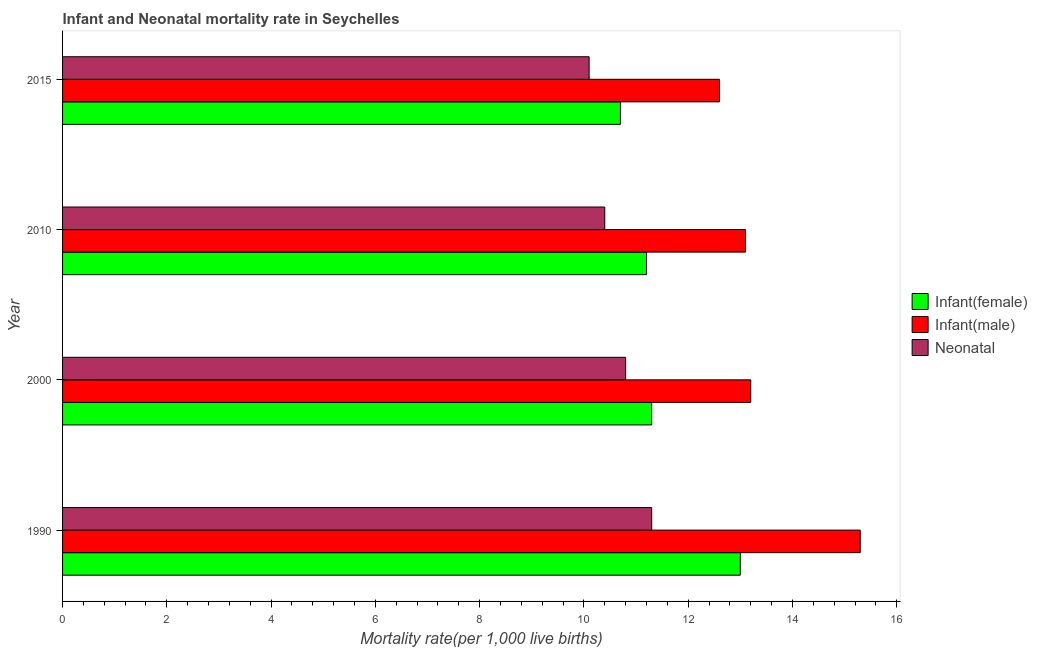How many groups of bars are there?
Provide a succinct answer. 4. How many bars are there on the 2nd tick from the top?
Your response must be concise. 3. How many bars are there on the 1st tick from the bottom?
Offer a very short reply. 3. What is the label of the 2nd group of bars from the top?
Offer a very short reply. 2010. Across all years, what is the minimum infant mortality rate(female)?
Offer a terse response. 10.7. In which year was the infant mortality rate(male) maximum?
Make the answer very short. 1990. In which year was the infant mortality rate(female) minimum?
Your answer should be very brief. 2015. What is the total infant mortality rate(male) in the graph?
Your answer should be very brief. 54.2. What is the difference between the neonatal mortality rate in 2010 and that in 2015?
Provide a short and direct response. 0.3. What is the difference between the infant mortality rate(female) in 2010 and the infant mortality rate(male) in 2015?
Provide a succinct answer. -1.4. What is the average infant mortality rate(male) per year?
Your answer should be very brief. 13.55. What is the ratio of the infant mortality rate(male) in 1990 to that in 2000?
Your answer should be very brief. 1.16. What is the difference between the highest and the lowest infant mortality rate(male)?
Provide a short and direct response. 2.7. Is the sum of the infant mortality rate(male) in 1990 and 2010 greater than the maximum neonatal mortality rate across all years?
Your response must be concise. Yes. What does the 3rd bar from the top in 2015 represents?
Give a very brief answer. Infant(female). What does the 2nd bar from the bottom in 1990 represents?
Give a very brief answer. Infant(male). Is it the case that in every year, the sum of the infant mortality rate(female) and infant mortality rate(male) is greater than the neonatal mortality rate?
Ensure brevity in your answer.  Yes. How many bars are there?
Offer a very short reply. 12. Are all the bars in the graph horizontal?
Keep it short and to the point. Yes. Are the values on the major ticks of X-axis written in scientific E-notation?
Your answer should be compact. No. Does the graph contain any zero values?
Keep it short and to the point. No. Where does the legend appear in the graph?
Keep it short and to the point. Center right. What is the title of the graph?
Your answer should be compact. Infant and Neonatal mortality rate in Seychelles. What is the label or title of the X-axis?
Keep it short and to the point. Mortality rate(per 1,0 live births). What is the Mortality rate(per 1,000 live births) of Infant(female) in 1990?
Provide a succinct answer. 13. What is the Mortality rate(per 1,000 live births) of Infant(male) in 1990?
Give a very brief answer. 15.3. What is the Mortality rate(per 1,000 live births) in Neonatal  in 2000?
Ensure brevity in your answer.  10.8. Across all years, what is the maximum Mortality rate(per 1,000 live births) in Infant(male)?
Offer a terse response. 15.3. Across all years, what is the maximum Mortality rate(per 1,000 live births) in Neonatal ?
Make the answer very short. 11.3. Across all years, what is the minimum Mortality rate(per 1,000 live births) of Infant(female)?
Your answer should be compact. 10.7. Across all years, what is the minimum Mortality rate(per 1,000 live births) of Neonatal ?
Your answer should be compact. 10.1. What is the total Mortality rate(per 1,000 live births) of Infant(female) in the graph?
Offer a terse response. 46.2. What is the total Mortality rate(per 1,000 live births) of Infant(male) in the graph?
Offer a terse response. 54.2. What is the total Mortality rate(per 1,000 live births) in Neonatal  in the graph?
Keep it short and to the point. 42.6. What is the difference between the Mortality rate(per 1,000 live births) in Infant(male) in 1990 and that in 2000?
Your answer should be compact. 2.1. What is the difference between the Mortality rate(per 1,000 live births) of Infant(male) in 1990 and that in 2010?
Provide a short and direct response. 2.2. What is the difference between the Mortality rate(per 1,000 live births) of Infant(female) in 2000 and that in 2010?
Provide a succinct answer. 0.1. What is the difference between the Mortality rate(per 1,000 live births) of Infant(male) in 2000 and that in 2010?
Your answer should be compact. 0.1. What is the difference between the Mortality rate(per 1,000 live births) of Infant(female) in 2000 and that in 2015?
Your answer should be compact. 0.6. What is the difference between the Mortality rate(per 1,000 live births) in Infant(male) in 2000 and that in 2015?
Offer a terse response. 0.6. What is the difference between the Mortality rate(per 1,000 live births) of Infant(male) in 2010 and that in 2015?
Ensure brevity in your answer.  0.5. What is the difference between the Mortality rate(per 1,000 live births) in Neonatal  in 2010 and that in 2015?
Ensure brevity in your answer.  0.3. What is the difference between the Mortality rate(per 1,000 live births) in Infant(female) in 1990 and the Mortality rate(per 1,000 live births) in Infant(male) in 2010?
Keep it short and to the point. -0.1. What is the difference between the Mortality rate(per 1,000 live births) in Infant(female) in 1990 and the Mortality rate(per 1,000 live births) in Neonatal  in 2010?
Make the answer very short. 2.6. What is the difference between the Mortality rate(per 1,000 live births) of Infant(male) in 1990 and the Mortality rate(per 1,000 live births) of Neonatal  in 2010?
Offer a very short reply. 4.9. What is the difference between the Mortality rate(per 1,000 live births) in Infant(female) in 1990 and the Mortality rate(per 1,000 live births) in Neonatal  in 2015?
Offer a terse response. 2.9. What is the difference between the Mortality rate(per 1,000 live births) of Infant(female) in 2000 and the Mortality rate(per 1,000 live births) of Neonatal  in 2010?
Offer a terse response. 0.9. What is the difference between the Mortality rate(per 1,000 live births) of Infant(male) in 2000 and the Mortality rate(per 1,000 live births) of Neonatal  in 2010?
Offer a very short reply. 2.8. What is the difference between the Mortality rate(per 1,000 live births) of Infant(male) in 2000 and the Mortality rate(per 1,000 live births) of Neonatal  in 2015?
Your answer should be compact. 3.1. What is the difference between the Mortality rate(per 1,000 live births) of Infant(female) in 2010 and the Mortality rate(per 1,000 live births) of Neonatal  in 2015?
Your answer should be very brief. 1.1. What is the difference between the Mortality rate(per 1,000 live births) in Infant(male) in 2010 and the Mortality rate(per 1,000 live births) in Neonatal  in 2015?
Provide a short and direct response. 3. What is the average Mortality rate(per 1,000 live births) in Infant(female) per year?
Provide a short and direct response. 11.55. What is the average Mortality rate(per 1,000 live births) of Infant(male) per year?
Keep it short and to the point. 13.55. What is the average Mortality rate(per 1,000 live births) of Neonatal  per year?
Offer a very short reply. 10.65. In the year 2000, what is the difference between the Mortality rate(per 1,000 live births) in Infant(female) and Mortality rate(per 1,000 live births) in Infant(male)?
Offer a very short reply. -1.9. In the year 2000, what is the difference between the Mortality rate(per 1,000 live births) of Infant(male) and Mortality rate(per 1,000 live births) of Neonatal ?
Ensure brevity in your answer.  2.4. In the year 2015, what is the difference between the Mortality rate(per 1,000 live births) of Infant(female) and Mortality rate(per 1,000 live births) of Neonatal ?
Provide a short and direct response. 0.6. What is the ratio of the Mortality rate(per 1,000 live births) of Infant(female) in 1990 to that in 2000?
Make the answer very short. 1.15. What is the ratio of the Mortality rate(per 1,000 live births) of Infant(male) in 1990 to that in 2000?
Provide a short and direct response. 1.16. What is the ratio of the Mortality rate(per 1,000 live births) in Neonatal  in 1990 to that in 2000?
Provide a succinct answer. 1.05. What is the ratio of the Mortality rate(per 1,000 live births) in Infant(female) in 1990 to that in 2010?
Your response must be concise. 1.16. What is the ratio of the Mortality rate(per 1,000 live births) of Infant(male) in 1990 to that in 2010?
Ensure brevity in your answer.  1.17. What is the ratio of the Mortality rate(per 1,000 live births) of Neonatal  in 1990 to that in 2010?
Provide a succinct answer. 1.09. What is the ratio of the Mortality rate(per 1,000 live births) in Infant(female) in 1990 to that in 2015?
Provide a succinct answer. 1.22. What is the ratio of the Mortality rate(per 1,000 live births) in Infant(male) in 1990 to that in 2015?
Ensure brevity in your answer.  1.21. What is the ratio of the Mortality rate(per 1,000 live births) in Neonatal  in 1990 to that in 2015?
Offer a very short reply. 1.12. What is the ratio of the Mortality rate(per 1,000 live births) of Infant(female) in 2000 to that in 2010?
Offer a terse response. 1.01. What is the ratio of the Mortality rate(per 1,000 live births) of Infant(male) in 2000 to that in 2010?
Offer a terse response. 1.01. What is the ratio of the Mortality rate(per 1,000 live births) of Neonatal  in 2000 to that in 2010?
Your answer should be very brief. 1.04. What is the ratio of the Mortality rate(per 1,000 live births) of Infant(female) in 2000 to that in 2015?
Provide a short and direct response. 1.06. What is the ratio of the Mortality rate(per 1,000 live births) of Infant(male) in 2000 to that in 2015?
Ensure brevity in your answer.  1.05. What is the ratio of the Mortality rate(per 1,000 live births) in Neonatal  in 2000 to that in 2015?
Your response must be concise. 1.07. What is the ratio of the Mortality rate(per 1,000 live births) in Infant(female) in 2010 to that in 2015?
Offer a terse response. 1.05. What is the ratio of the Mortality rate(per 1,000 live births) of Infant(male) in 2010 to that in 2015?
Make the answer very short. 1.04. What is the ratio of the Mortality rate(per 1,000 live births) in Neonatal  in 2010 to that in 2015?
Keep it short and to the point. 1.03. What is the difference between the highest and the second highest Mortality rate(per 1,000 live births) of Infant(male)?
Your answer should be very brief. 2.1. What is the difference between the highest and the lowest Mortality rate(per 1,000 live births) of Infant(female)?
Keep it short and to the point. 2.3. What is the difference between the highest and the lowest Mortality rate(per 1,000 live births) in Neonatal ?
Make the answer very short. 1.2. 